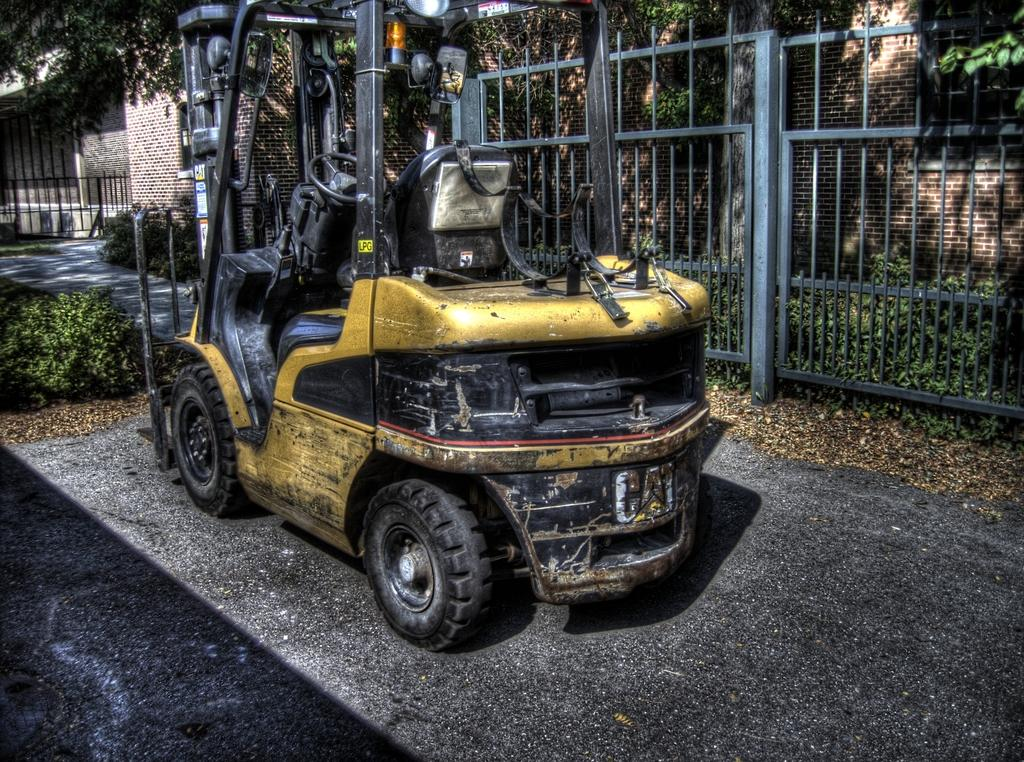What is on the road in the image? There is a vehicle on the road in the image. What type of natural elements can be seen in the image? There are trees visible in the image. What type of barrier is present in the image? There is a fence in the image. What can be seen in the background of the image? There is a wall in the background of the image. Where is the tub located in the image? There is no tub present in the image. What type of flower can be seen growing near the wall in the image? There is no flower visible in the image; only trees, a fence, and a wall are present. 